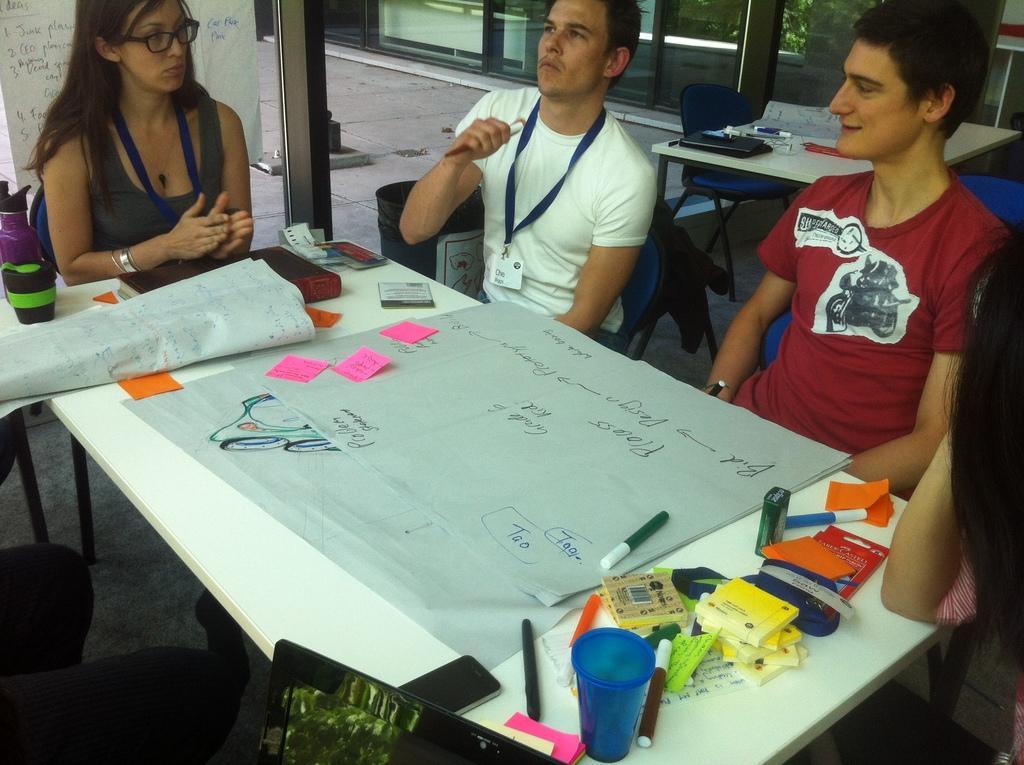Describe this image in one or two sentences. In this picture i could see three persons sitting on the chairs beside the dining table and working on some paper. The left corner a girl with the specs seems like explaining something and the boy beside her wearing a white t shirt is holding a pen and the other person to the white t shirt is wearing a red t shirt and giving a smile. There are some charts, sketch pens, glass bottles, and booklets on the table top. The table is white in color and in the background i could see some glass doors. 